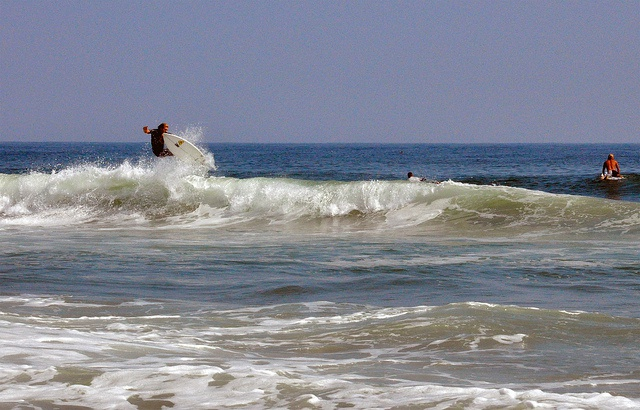Describe the objects in this image and their specific colors. I can see surfboard in gray, darkgray, and lightgray tones, people in gray, black, and maroon tones, people in gray, black, and maroon tones, people in gray, darkgray, black, and lightgray tones, and surfboard in gray, black, darkgray, and maroon tones in this image. 